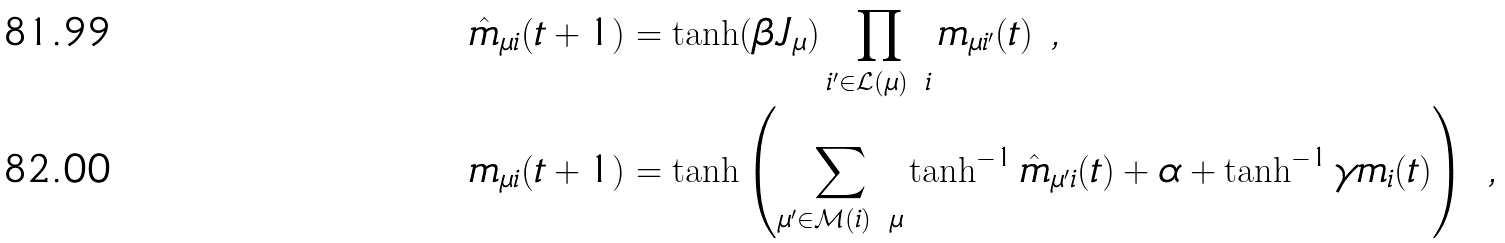<formula> <loc_0><loc_0><loc_500><loc_500>\hat { m } _ { \mu i } ( t + 1 ) & = \tanh ( \beta J _ { \mu } ) \prod _ { i ^ { \prime } \in \mathcal { L } ( \mu ) \ i } m _ { \mu i ^ { \prime } } ( t ) \ , \\ m _ { \mu i } ( t + 1 ) & = \tanh \left ( \sum _ { \mu ^ { \prime } \in \mathcal { M } ( i ) \ \mu } \tanh ^ { - 1 } \hat { m } _ { \mu ^ { \prime } i } ( t ) + \alpha + \tanh ^ { - 1 } \gamma m _ { i } ( t ) \right ) \ ,</formula> 